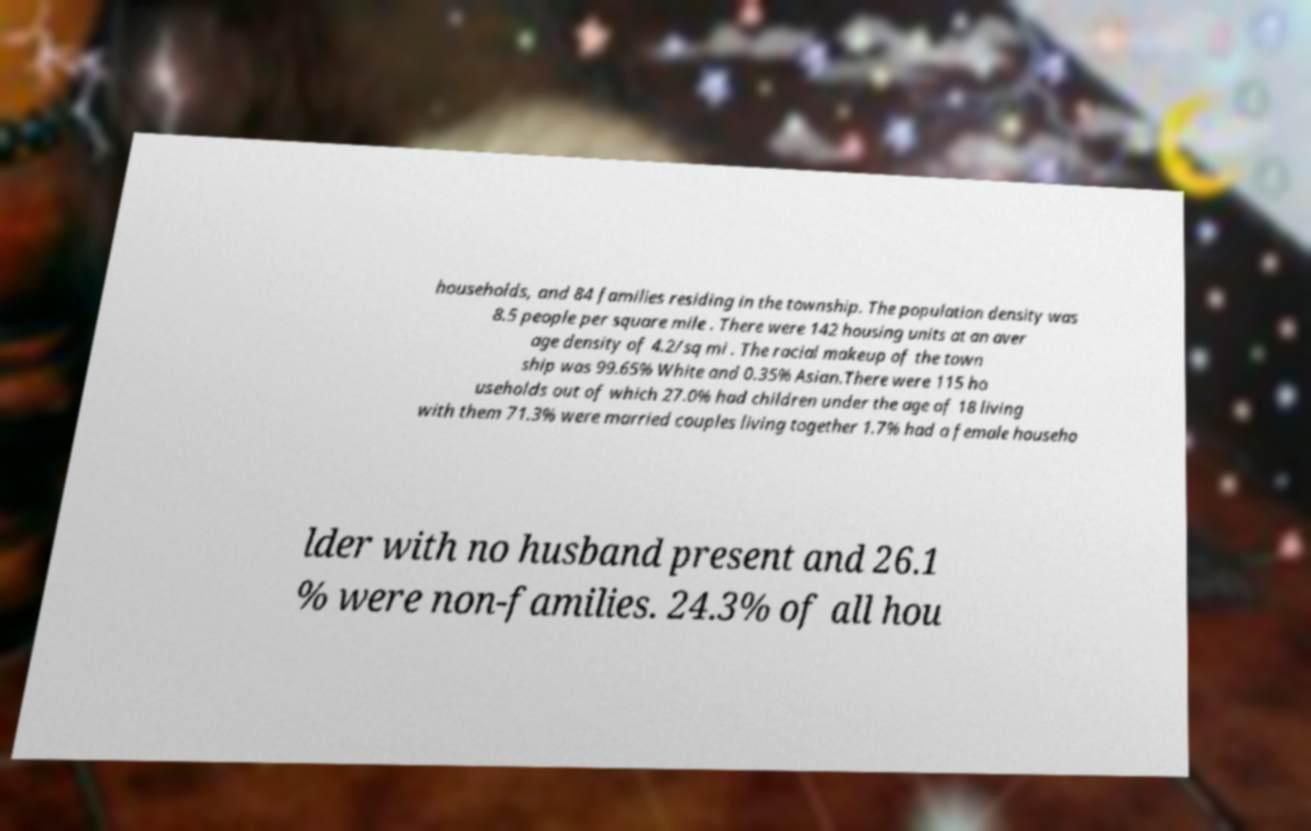Please read and relay the text visible in this image. What does it say? households, and 84 families residing in the township. The population density was 8.5 people per square mile . There were 142 housing units at an aver age density of 4.2/sq mi . The racial makeup of the town ship was 99.65% White and 0.35% Asian.There were 115 ho useholds out of which 27.0% had children under the age of 18 living with them 71.3% were married couples living together 1.7% had a female househo lder with no husband present and 26.1 % were non-families. 24.3% of all hou 